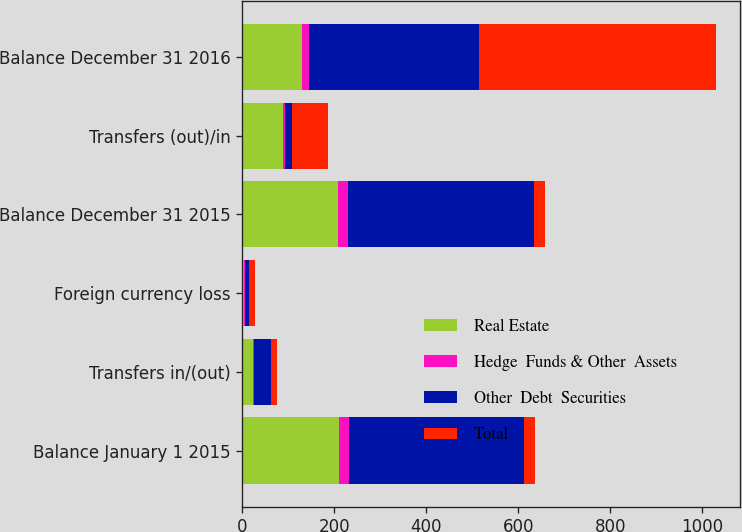Convert chart to OTSL. <chart><loc_0><loc_0><loc_500><loc_500><stacked_bar_chart><ecel><fcel>Balance January 1 2015<fcel>Transfers in/(out)<fcel>Foreign currency loss<fcel>Balance December 31 2015<fcel>Transfers (out)/in<fcel>Balance December 31 2016<nl><fcel>Real Estate<fcel>210<fcel>24<fcel>4<fcel>209<fcel>88<fcel>129<nl><fcel>Hedge  Funds & Other  Assets<fcel>23<fcel>1<fcel>2<fcel>21<fcel>5<fcel>16<nl><fcel>Other  Debt  Securities<fcel>379<fcel>38<fcel>8<fcel>405<fcel>16<fcel>370<nl><fcel>Total<fcel>23.5<fcel>13<fcel>14<fcel>23.5<fcel>77<fcel>515<nl></chart> 